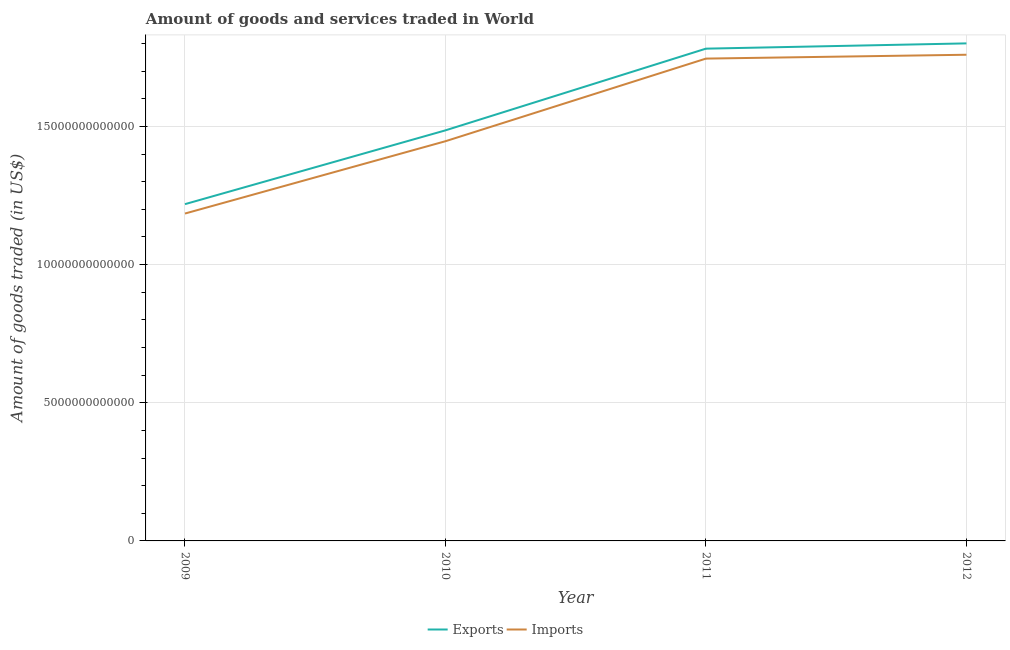Does the line corresponding to amount of goods exported intersect with the line corresponding to amount of goods imported?
Your response must be concise. No. Is the number of lines equal to the number of legend labels?
Your response must be concise. Yes. What is the amount of goods exported in 2011?
Provide a succinct answer. 1.78e+13. Across all years, what is the maximum amount of goods imported?
Ensure brevity in your answer.  1.76e+13. Across all years, what is the minimum amount of goods imported?
Ensure brevity in your answer.  1.18e+13. In which year was the amount of goods imported maximum?
Keep it short and to the point. 2012. In which year was the amount of goods exported minimum?
Offer a very short reply. 2009. What is the total amount of goods exported in the graph?
Provide a short and direct response. 6.29e+13. What is the difference between the amount of goods exported in 2010 and that in 2011?
Ensure brevity in your answer.  -2.96e+12. What is the difference between the amount of goods exported in 2012 and the amount of goods imported in 2009?
Your answer should be very brief. 6.16e+12. What is the average amount of goods imported per year?
Offer a very short reply. 1.53e+13. In the year 2011, what is the difference between the amount of goods exported and amount of goods imported?
Offer a terse response. 3.60e+11. What is the ratio of the amount of goods exported in 2009 to that in 2010?
Make the answer very short. 0.82. Is the difference between the amount of goods exported in 2011 and 2012 greater than the difference between the amount of goods imported in 2011 and 2012?
Offer a terse response. No. What is the difference between the highest and the second highest amount of goods imported?
Keep it short and to the point. 1.39e+11. What is the difference between the highest and the lowest amount of goods imported?
Your response must be concise. 5.75e+12. In how many years, is the amount of goods exported greater than the average amount of goods exported taken over all years?
Your response must be concise. 2. Is the sum of the amount of goods exported in 2009 and 2012 greater than the maximum amount of goods imported across all years?
Offer a very short reply. Yes. Does the amount of goods imported monotonically increase over the years?
Your answer should be very brief. Yes. Is the amount of goods imported strictly less than the amount of goods exported over the years?
Make the answer very short. Yes. How many lines are there?
Give a very brief answer. 2. What is the difference between two consecutive major ticks on the Y-axis?
Your answer should be very brief. 5.00e+12. How many legend labels are there?
Ensure brevity in your answer.  2. How are the legend labels stacked?
Offer a terse response. Horizontal. What is the title of the graph?
Your answer should be compact. Amount of goods and services traded in World. Does "% of gross capital formation" appear as one of the legend labels in the graph?
Make the answer very short. No. What is the label or title of the Y-axis?
Ensure brevity in your answer.  Amount of goods traded (in US$). What is the Amount of goods traded (in US$) in Exports in 2009?
Ensure brevity in your answer.  1.22e+13. What is the Amount of goods traded (in US$) of Imports in 2009?
Your response must be concise. 1.18e+13. What is the Amount of goods traded (in US$) of Exports in 2010?
Your response must be concise. 1.49e+13. What is the Amount of goods traded (in US$) of Imports in 2010?
Provide a succinct answer. 1.45e+13. What is the Amount of goods traded (in US$) of Exports in 2011?
Offer a very short reply. 1.78e+13. What is the Amount of goods traded (in US$) of Imports in 2011?
Ensure brevity in your answer.  1.75e+13. What is the Amount of goods traded (in US$) in Exports in 2012?
Give a very brief answer. 1.80e+13. What is the Amount of goods traded (in US$) in Imports in 2012?
Ensure brevity in your answer.  1.76e+13. Across all years, what is the maximum Amount of goods traded (in US$) of Exports?
Your response must be concise. 1.80e+13. Across all years, what is the maximum Amount of goods traded (in US$) in Imports?
Ensure brevity in your answer.  1.76e+13. Across all years, what is the minimum Amount of goods traded (in US$) in Exports?
Provide a succinct answer. 1.22e+13. Across all years, what is the minimum Amount of goods traded (in US$) of Imports?
Keep it short and to the point. 1.18e+13. What is the total Amount of goods traded (in US$) in Exports in the graph?
Make the answer very short. 6.29e+13. What is the total Amount of goods traded (in US$) in Imports in the graph?
Give a very brief answer. 6.14e+13. What is the difference between the Amount of goods traded (in US$) in Exports in 2009 and that in 2010?
Your answer should be very brief. -2.67e+12. What is the difference between the Amount of goods traded (in US$) in Imports in 2009 and that in 2010?
Give a very brief answer. -2.62e+12. What is the difference between the Amount of goods traded (in US$) in Exports in 2009 and that in 2011?
Your answer should be compact. -5.63e+12. What is the difference between the Amount of goods traded (in US$) in Imports in 2009 and that in 2011?
Make the answer very short. -5.61e+12. What is the difference between the Amount of goods traded (in US$) in Exports in 2009 and that in 2012?
Your answer should be compact. -5.82e+12. What is the difference between the Amount of goods traded (in US$) of Imports in 2009 and that in 2012?
Your answer should be very brief. -5.75e+12. What is the difference between the Amount of goods traded (in US$) in Exports in 2010 and that in 2011?
Make the answer very short. -2.96e+12. What is the difference between the Amount of goods traded (in US$) of Imports in 2010 and that in 2011?
Your answer should be very brief. -2.99e+12. What is the difference between the Amount of goods traded (in US$) of Exports in 2010 and that in 2012?
Offer a very short reply. -3.15e+12. What is the difference between the Amount of goods traded (in US$) of Imports in 2010 and that in 2012?
Provide a succinct answer. -3.13e+12. What is the difference between the Amount of goods traded (in US$) in Exports in 2011 and that in 2012?
Your response must be concise. -1.91e+11. What is the difference between the Amount of goods traded (in US$) in Imports in 2011 and that in 2012?
Your response must be concise. -1.39e+11. What is the difference between the Amount of goods traded (in US$) in Exports in 2009 and the Amount of goods traded (in US$) in Imports in 2010?
Ensure brevity in your answer.  -2.28e+12. What is the difference between the Amount of goods traded (in US$) in Exports in 2009 and the Amount of goods traded (in US$) in Imports in 2011?
Provide a succinct answer. -5.27e+12. What is the difference between the Amount of goods traded (in US$) of Exports in 2009 and the Amount of goods traded (in US$) of Imports in 2012?
Provide a succinct answer. -5.41e+12. What is the difference between the Amount of goods traded (in US$) in Exports in 2010 and the Amount of goods traded (in US$) in Imports in 2011?
Make the answer very short. -2.60e+12. What is the difference between the Amount of goods traded (in US$) in Exports in 2010 and the Amount of goods traded (in US$) in Imports in 2012?
Make the answer very short. -2.74e+12. What is the difference between the Amount of goods traded (in US$) of Exports in 2011 and the Amount of goods traded (in US$) of Imports in 2012?
Provide a succinct answer. 2.21e+11. What is the average Amount of goods traded (in US$) of Exports per year?
Your answer should be compact. 1.57e+13. What is the average Amount of goods traded (in US$) of Imports per year?
Your answer should be compact. 1.53e+13. In the year 2009, what is the difference between the Amount of goods traded (in US$) in Exports and Amount of goods traded (in US$) in Imports?
Ensure brevity in your answer.  3.40e+11. In the year 2010, what is the difference between the Amount of goods traded (in US$) of Exports and Amount of goods traded (in US$) of Imports?
Your answer should be compact. 3.94e+11. In the year 2011, what is the difference between the Amount of goods traded (in US$) in Exports and Amount of goods traded (in US$) in Imports?
Ensure brevity in your answer.  3.60e+11. In the year 2012, what is the difference between the Amount of goods traded (in US$) in Exports and Amount of goods traded (in US$) in Imports?
Ensure brevity in your answer.  4.11e+11. What is the ratio of the Amount of goods traded (in US$) of Exports in 2009 to that in 2010?
Give a very brief answer. 0.82. What is the ratio of the Amount of goods traded (in US$) in Imports in 2009 to that in 2010?
Offer a very short reply. 0.82. What is the ratio of the Amount of goods traded (in US$) of Exports in 2009 to that in 2011?
Offer a terse response. 0.68. What is the ratio of the Amount of goods traded (in US$) in Imports in 2009 to that in 2011?
Provide a short and direct response. 0.68. What is the ratio of the Amount of goods traded (in US$) of Exports in 2009 to that in 2012?
Provide a succinct answer. 0.68. What is the ratio of the Amount of goods traded (in US$) in Imports in 2009 to that in 2012?
Offer a very short reply. 0.67. What is the ratio of the Amount of goods traded (in US$) in Exports in 2010 to that in 2011?
Give a very brief answer. 0.83. What is the ratio of the Amount of goods traded (in US$) in Imports in 2010 to that in 2011?
Provide a succinct answer. 0.83. What is the ratio of the Amount of goods traded (in US$) in Exports in 2010 to that in 2012?
Offer a terse response. 0.83. What is the ratio of the Amount of goods traded (in US$) in Imports in 2010 to that in 2012?
Provide a succinct answer. 0.82. What is the ratio of the Amount of goods traded (in US$) of Exports in 2011 to that in 2012?
Your answer should be compact. 0.99. What is the difference between the highest and the second highest Amount of goods traded (in US$) of Exports?
Provide a succinct answer. 1.91e+11. What is the difference between the highest and the second highest Amount of goods traded (in US$) of Imports?
Your answer should be very brief. 1.39e+11. What is the difference between the highest and the lowest Amount of goods traded (in US$) in Exports?
Give a very brief answer. 5.82e+12. What is the difference between the highest and the lowest Amount of goods traded (in US$) in Imports?
Provide a succinct answer. 5.75e+12. 